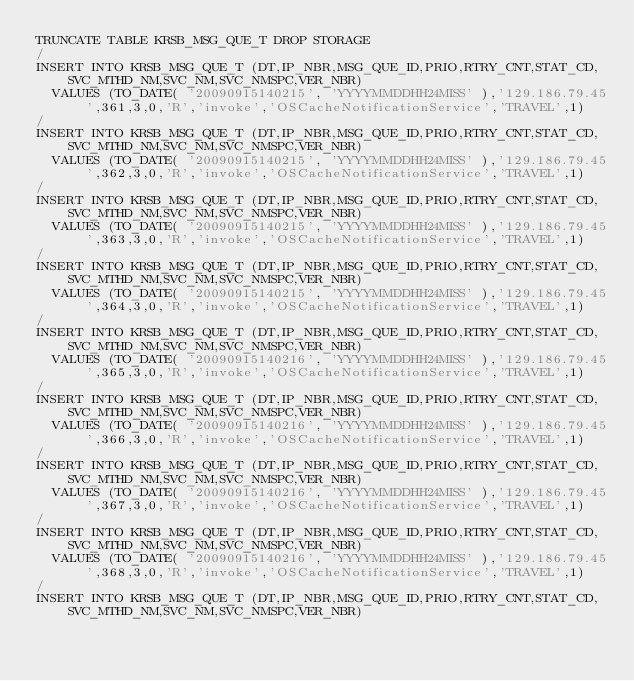<code> <loc_0><loc_0><loc_500><loc_500><_SQL_>TRUNCATE TABLE KRSB_MSG_QUE_T DROP STORAGE
/
INSERT INTO KRSB_MSG_QUE_T (DT,IP_NBR,MSG_QUE_ID,PRIO,RTRY_CNT,STAT_CD,SVC_MTHD_NM,SVC_NM,SVC_NMSPC,VER_NBR)
  VALUES (TO_DATE( '20090915140215', 'YYYYMMDDHH24MISS' ),'129.186.79.45',361,3,0,'R','invoke','OSCacheNotificationService','TRAVEL',1)
/
INSERT INTO KRSB_MSG_QUE_T (DT,IP_NBR,MSG_QUE_ID,PRIO,RTRY_CNT,STAT_CD,SVC_MTHD_NM,SVC_NM,SVC_NMSPC,VER_NBR)
  VALUES (TO_DATE( '20090915140215', 'YYYYMMDDHH24MISS' ),'129.186.79.45',362,3,0,'R','invoke','OSCacheNotificationService','TRAVEL',1)
/
INSERT INTO KRSB_MSG_QUE_T (DT,IP_NBR,MSG_QUE_ID,PRIO,RTRY_CNT,STAT_CD,SVC_MTHD_NM,SVC_NM,SVC_NMSPC,VER_NBR)
  VALUES (TO_DATE( '20090915140215', 'YYYYMMDDHH24MISS' ),'129.186.79.45',363,3,0,'R','invoke','OSCacheNotificationService','TRAVEL',1)
/
INSERT INTO KRSB_MSG_QUE_T (DT,IP_NBR,MSG_QUE_ID,PRIO,RTRY_CNT,STAT_CD,SVC_MTHD_NM,SVC_NM,SVC_NMSPC,VER_NBR)
  VALUES (TO_DATE( '20090915140215', 'YYYYMMDDHH24MISS' ),'129.186.79.45',364,3,0,'R','invoke','OSCacheNotificationService','TRAVEL',1)
/
INSERT INTO KRSB_MSG_QUE_T (DT,IP_NBR,MSG_QUE_ID,PRIO,RTRY_CNT,STAT_CD,SVC_MTHD_NM,SVC_NM,SVC_NMSPC,VER_NBR)
  VALUES (TO_DATE( '20090915140216', 'YYYYMMDDHH24MISS' ),'129.186.79.45',365,3,0,'R','invoke','OSCacheNotificationService','TRAVEL',1)
/
INSERT INTO KRSB_MSG_QUE_T (DT,IP_NBR,MSG_QUE_ID,PRIO,RTRY_CNT,STAT_CD,SVC_MTHD_NM,SVC_NM,SVC_NMSPC,VER_NBR)
  VALUES (TO_DATE( '20090915140216', 'YYYYMMDDHH24MISS' ),'129.186.79.45',366,3,0,'R','invoke','OSCacheNotificationService','TRAVEL',1)
/
INSERT INTO KRSB_MSG_QUE_T (DT,IP_NBR,MSG_QUE_ID,PRIO,RTRY_CNT,STAT_CD,SVC_MTHD_NM,SVC_NM,SVC_NMSPC,VER_NBR)
  VALUES (TO_DATE( '20090915140216', 'YYYYMMDDHH24MISS' ),'129.186.79.45',367,3,0,'R','invoke','OSCacheNotificationService','TRAVEL',1)
/
INSERT INTO KRSB_MSG_QUE_T (DT,IP_NBR,MSG_QUE_ID,PRIO,RTRY_CNT,STAT_CD,SVC_MTHD_NM,SVC_NM,SVC_NMSPC,VER_NBR)
  VALUES (TO_DATE( '20090915140216', 'YYYYMMDDHH24MISS' ),'129.186.79.45',368,3,0,'R','invoke','OSCacheNotificationService','TRAVEL',1)
/
INSERT INTO KRSB_MSG_QUE_T (DT,IP_NBR,MSG_QUE_ID,PRIO,RTRY_CNT,STAT_CD,SVC_MTHD_NM,SVC_NM,SVC_NMSPC,VER_NBR)</code> 